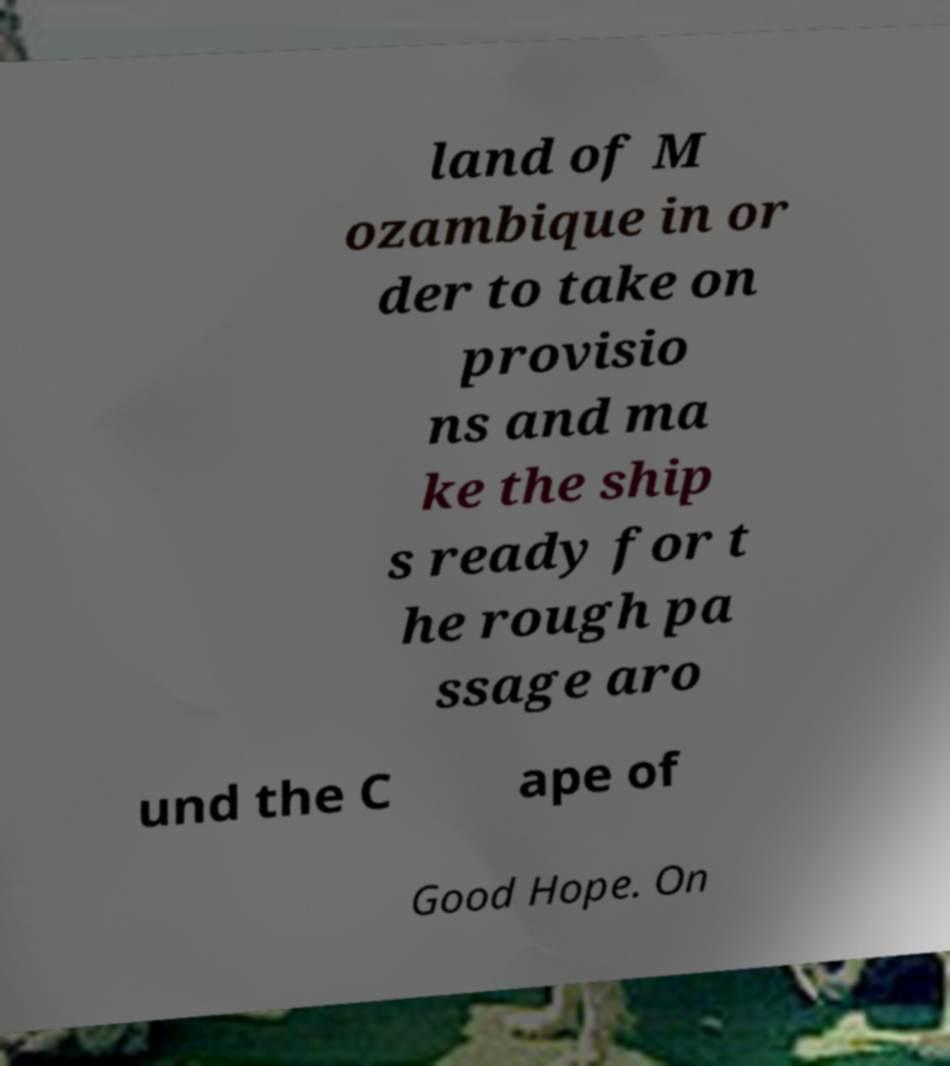Could you extract and type out the text from this image? land of M ozambique in or der to take on provisio ns and ma ke the ship s ready for t he rough pa ssage aro und the C ape of Good Hope. On 